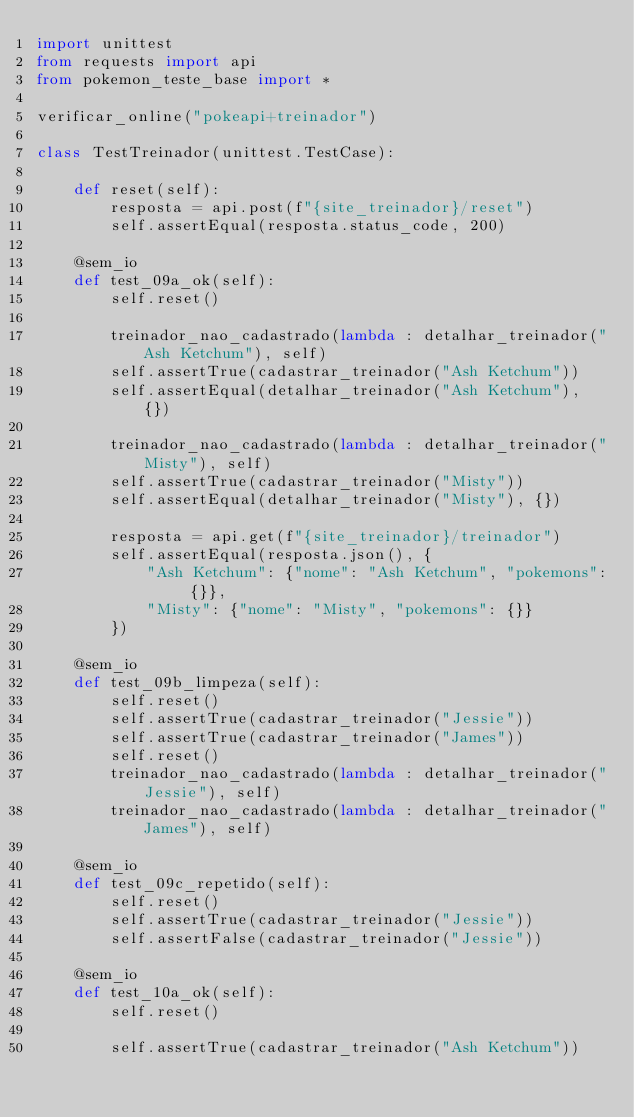<code> <loc_0><loc_0><loc_500><loc_500><_Python_>import unittest
from requests import api
from pokemon_teste_base import *

verificar_online("pokeapi+treinador")

class TestTreinador(unittest.TestCase):

    def reset(self):
        resposta = api.post(f"{site_treinador}/reset")
        self.assertEqual(resposta.status_code, 200)

    @sem_io
    def test_09a_ok(self):
        self.reset()

        treinador_nao_cadastrado(lambda : detalhar_treinador("Ash Ketchum"), self)
        self.assertTrue(cadastrar_treinador("Ash Ketchum"))
        self.assertEqual(detalhar_treinador("Ash Ketchum"), {})

        treinador_nao_cadastrado(lambda : detalhar_treinador("Misty"), self)
        self.assertTrue(cadastrar_treinador("Misty"))
        self.assertEqual(detalhar_treinador("Misty"), {})

        resposta = api.get(f"{site_treinador}/treinador")
        self.assertEqual(resposta.json(), {
            "Ash Ketchum": {"nome": "Ash Ketchum", "pokemons": {}},
            "Misty": {"nome": "Misty", "pokemons": {}}
        })

    @sem_io
    def test_09b_limpeza(self):
        self.reset()
        self.assertTrue(cadastrar_treinador("Jessie"))
        self.assertTrue(cadastrar_treinador("James"))
        self.reset()
        treinador_nao_cadastrado(lambda : detalhar_treinador("Jessie"), self)
        treinador_nao_cadastrado(lambda : detalhar_treinador("James"), self)

    @sem_io
    def test_09c_repetido(self):
        self.reset()
        self.assertTrue(cadastrar_treinador("Jessie"))
        self.assertFalse(cadastrar_treinador("Jessie"))
    
    @sem_io
    def test_10a_ok(self):
        self.reset()

        self.assertTrue(cadastrar_treinador("Ash Ketchum"))</code> 